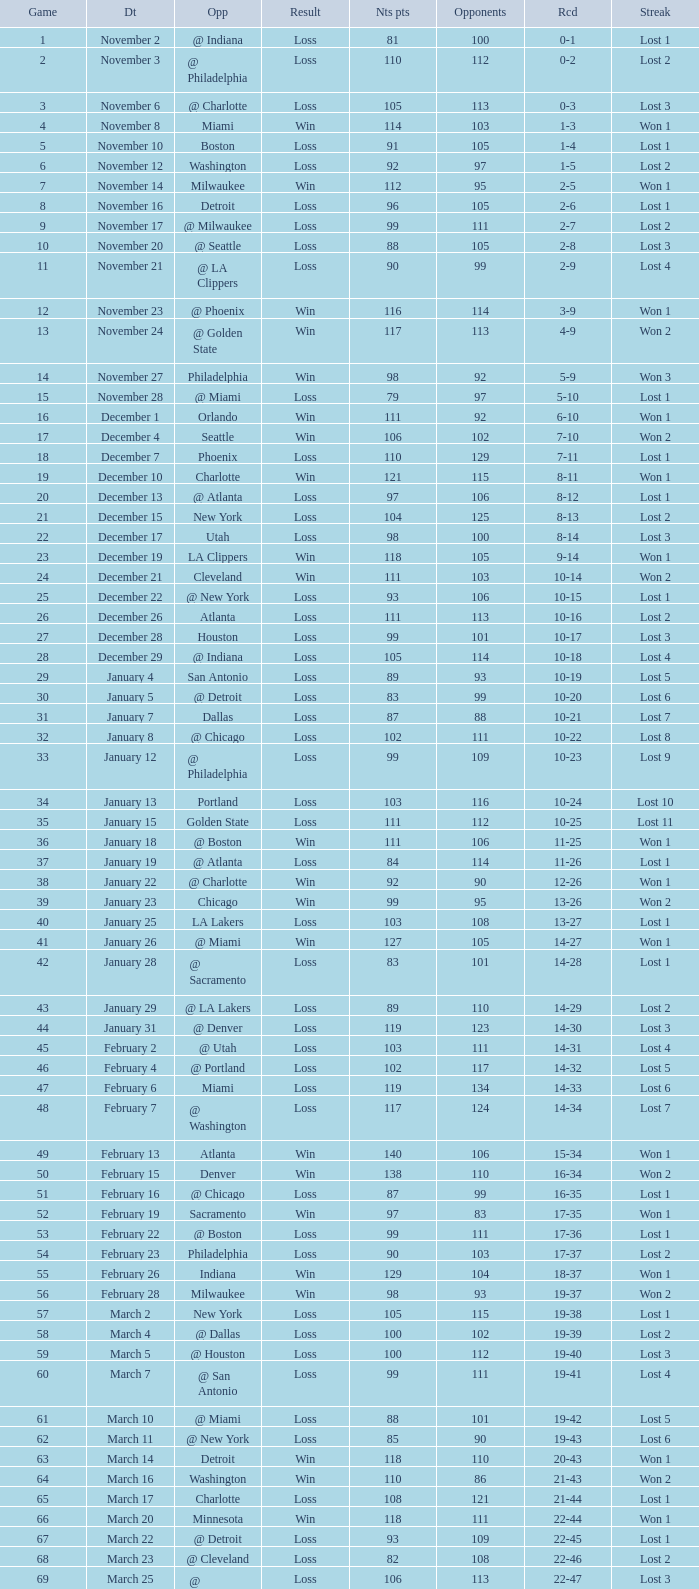What was the average point total for the nets in games before game 9 where the opponents scored less than 95? None. 